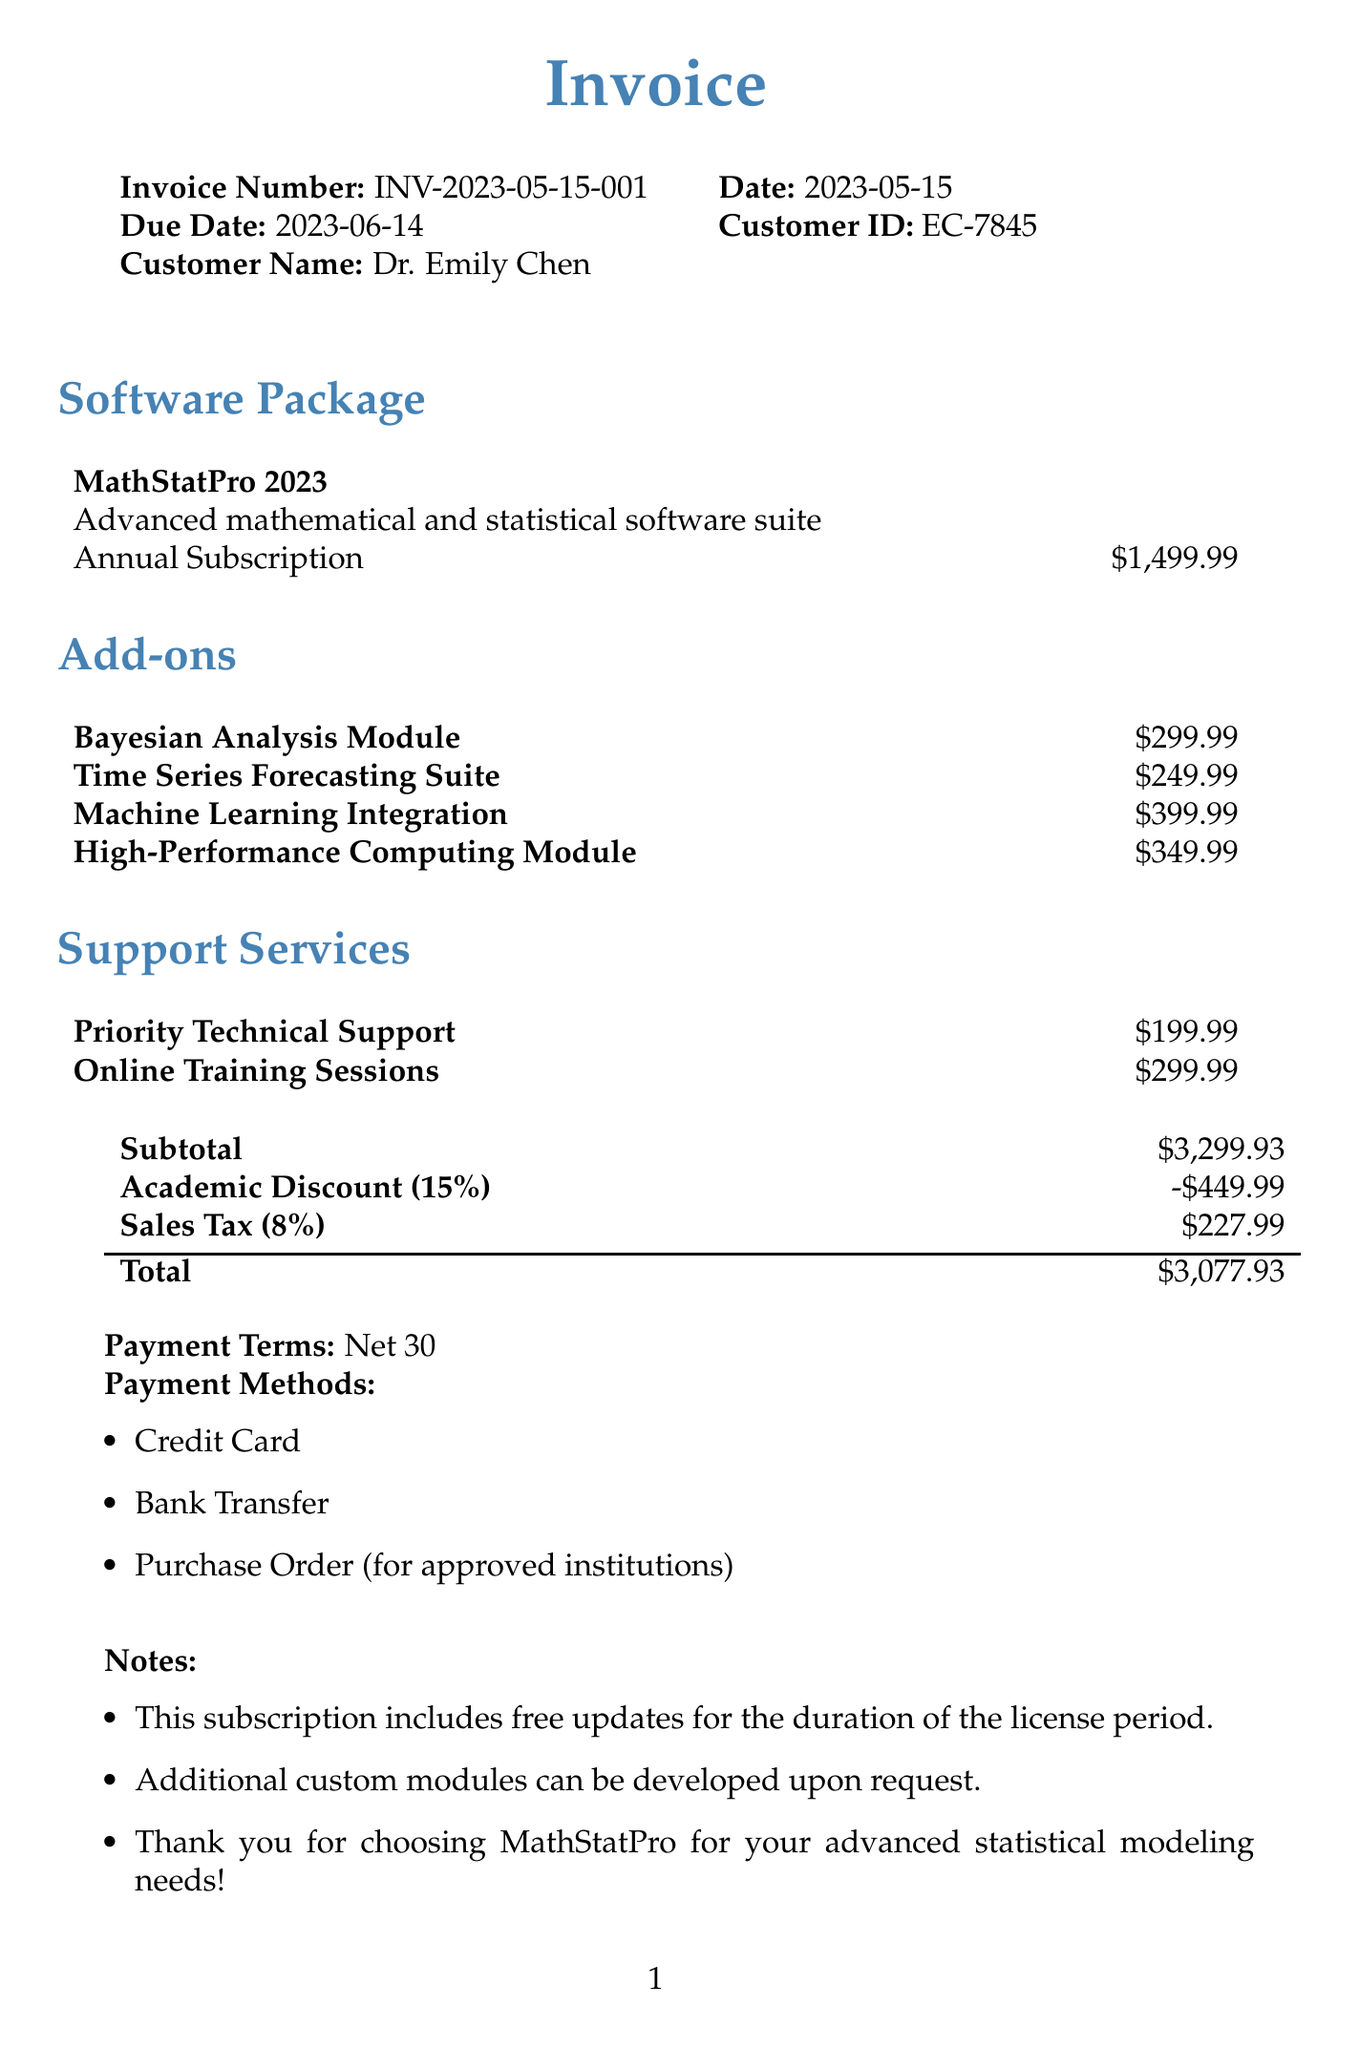What is the invoice number? The invoice number is a unique identifier for the invoice, found in the document header.
Answer: INV-2023-05-15-001 Who is the customer? The customer is the individual or entity receiving the invoice, identified in the document.
Answer: Dr. Emily Chen What is the base price of the software package? The base price is the cost of the main software package, clearly stated in the invoice.
Answer: $1,499.99 What is the total amount due for this invoice? The total amount is the final figure that includes all charges, discounts, and taxes.
Answer: $3,077.93 How much is the academic discount? The academic discount is the amount subtracted from the subtotal for eligible customers.
Answer: -$449.99 What support service has 24/7 access? This service provides round-the-clock support to the customer, as mentioned in the support services section.
Answer: Priority Technical Support How many hours of online training sessions are included? The number of hours provided for the training sessions is specified in the support services section.
Answer: 10 hours What is the payment term? This specifies the time frame allowed for payment of the invoice, found towards the end of the document.
Answer: Net 30 When is the due date for this invoice? The due date indicates when payment is expected, located in the document header.
Answer: 2023-06-14 